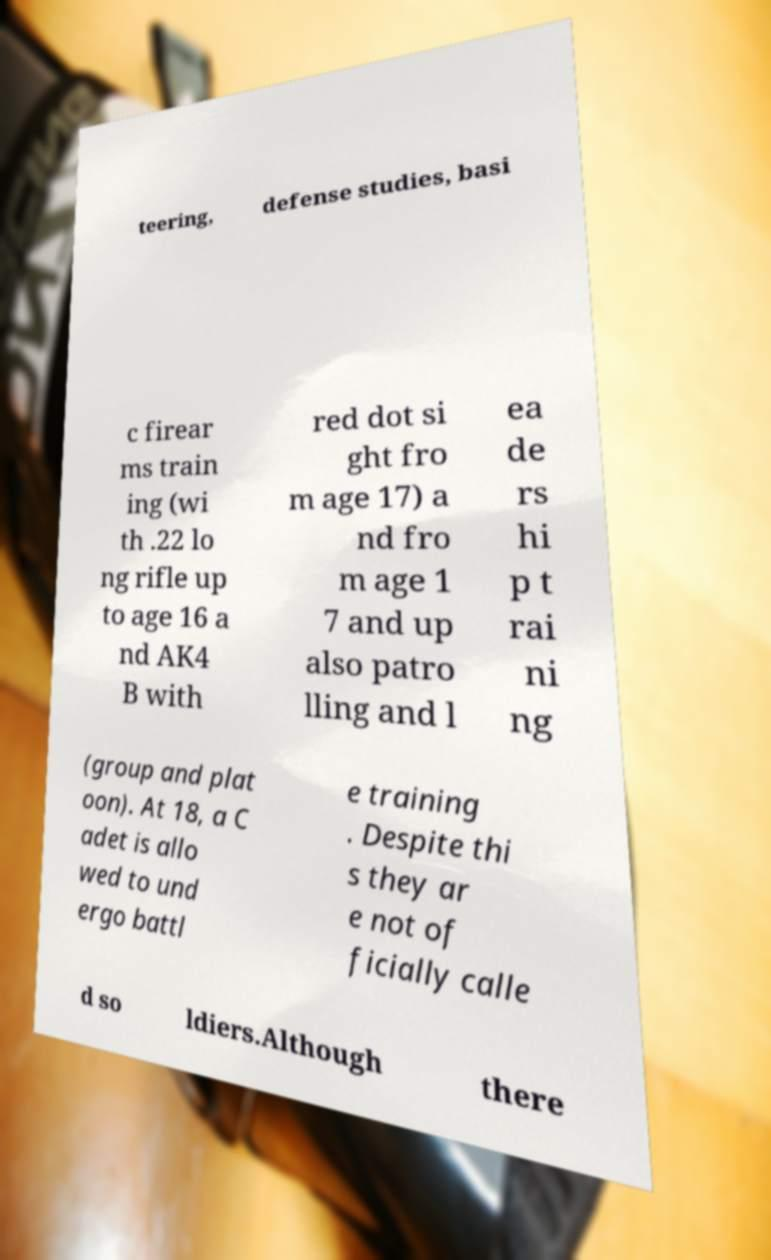Please identify and transcribe the text found in this image. teering, defense studies, basi c firear ms train ing (wi th .22 lo ng rifle up to age 16 a nd AK4 B with red dot si ght fro m age 17) a nd fro m age 1 7 and up also patro lling and l ea de rs hi p t rai ni ng (group and plat oon). At 18, a C adet is allo wed to und ergo battl e training . Despite thi s they ar e not of ficially calle d so ldiers.Although there 